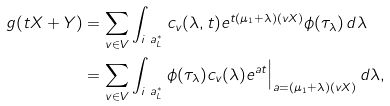Convert formula to latex. <formula><loc_0><loc_0><loc_500><loc_500>g ( t X + Y ) & = \sum _ { v \in V } \int _ { i \ a _ { L } ^ { * } } c _ { v } ( \lambda , t ) e ^ { t ( \mu _ { 1 } + \lambda ) ( v X ) } \phi ( \tau _ { \lambda } ) \, d \lambda \\ & = \sum _ { v \in V } \int _ { i \ a _ { L } ^ { * } } \phi ( \tau _ { \lambda } ) c _ { v } ( \lambda ) e ^ { a t } \Big | _ { a = ( \mu _ { 1 } + \lambda ) ( v X ) } \, d \lambda ,</formula> 